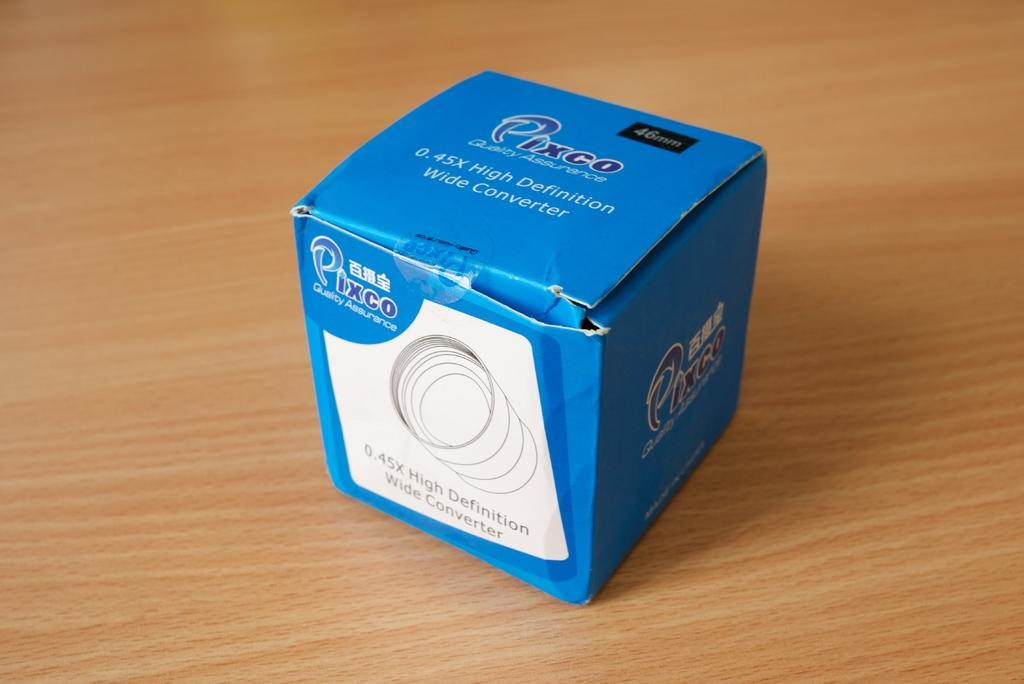Provide a one-sentence caption for the provided image. A blue and white box that is from the company Pixco contains a high definition wide converter. 